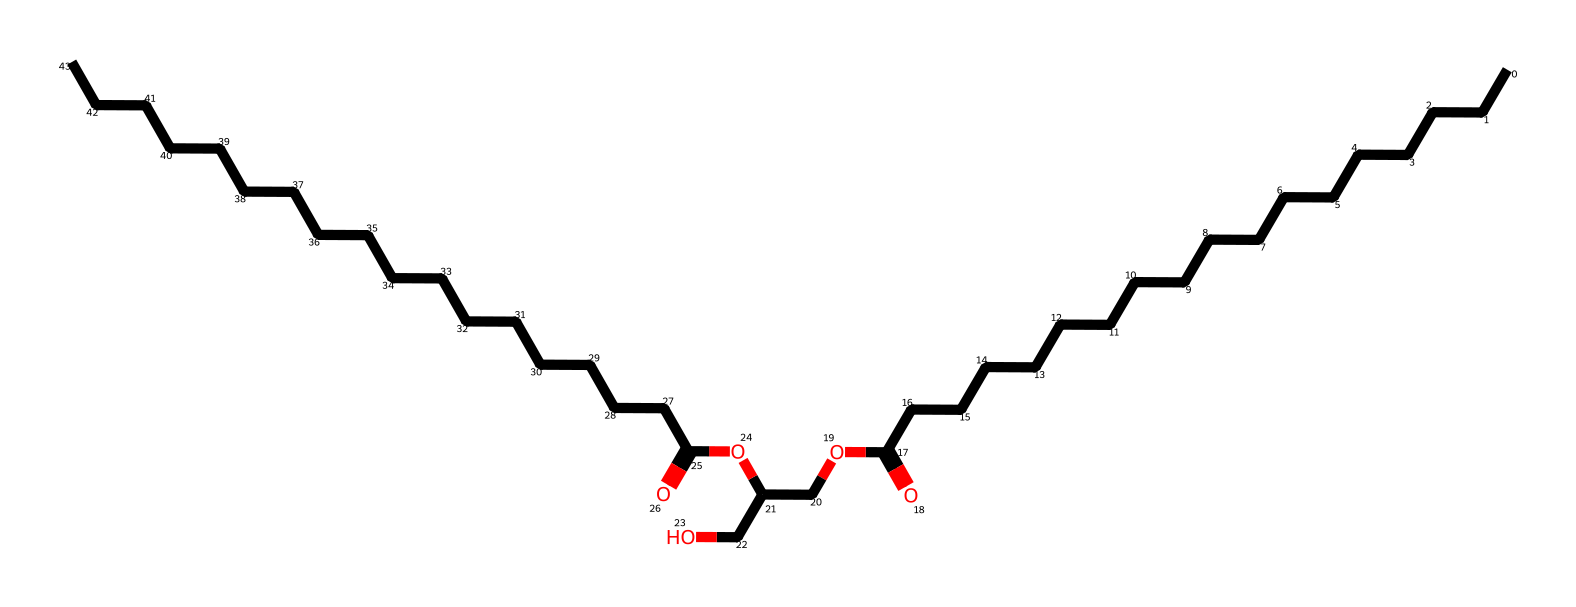What is the chemical name of this structure? The SMILES notation indicates that the chemical is glyceryl stearate, an ester derived from glycerol and stearic acid.
Answer: glyceryl stearate How many carbon atoms are in glyceryl stearate? By examining the structure, there are 34 carbon atoms present in the entire molecule: 18 from stearic acid and 3 from glycerol.
Answer: 34 What type of chemical bond connects the carbon and oxygen in the ester functional group? The bond connecting carbon and oxygen in the ester functional group is a single bond (C-O), which is characteristic of esters.
Answer: single bond Which part of glyceryl stearate is hydrophilic? The glycerol part of the molecule, which includes the -OH groups, is hydrophilic and allows interaction with water.
Answer: glycerol Is glyceryl stearate a surfactant? Yes, glyceryl stearate acts as a surfactant due to its amphiphilic nature, which allows it to stabilize oil-in-water emulsions.
Answer: yes How many double bonds are present in glyceryl stearate? There are no double bonds present in the molecule as indicated by the structure derived from stearic acid and glycerol.
Answer: 0 What role does glyceryl stearate play in face paint? Glyceryl stearate acts as an emulsifier that helps to blend oil and water components in the formulation of face paint.
Answer: emulsifier 